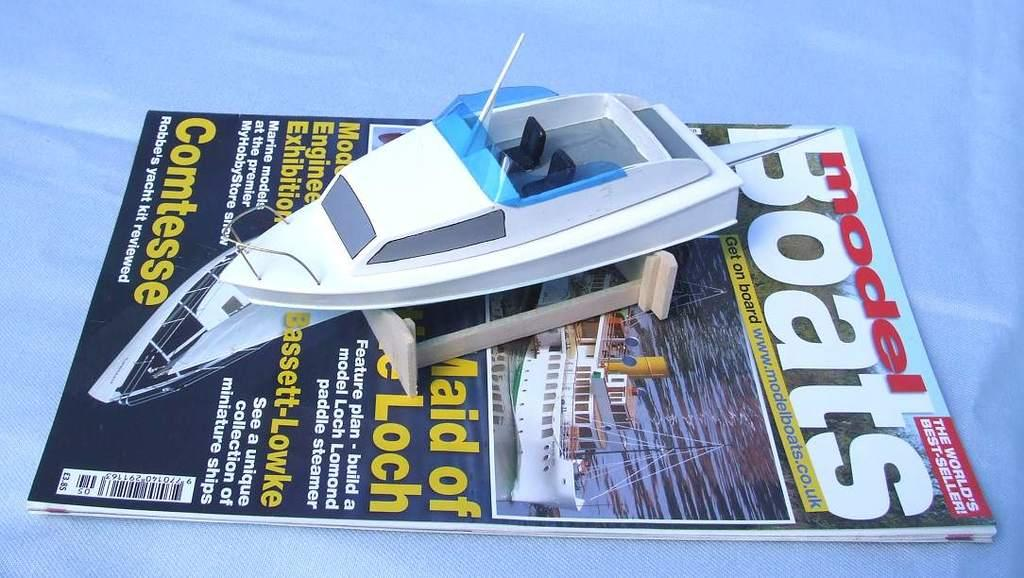Provide a one-sentence caption for the provided image. the word boats that is on a magazine. 